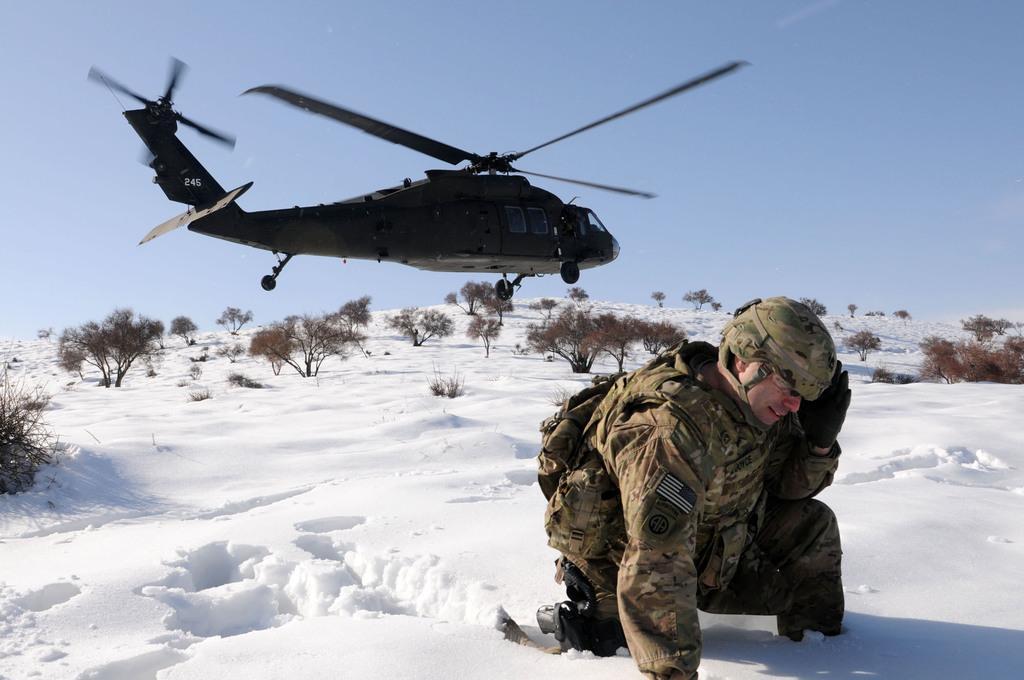In one or two sentences, can you explain what this image depicts? In this picture we can see a person on snow, trees, helicopter in the air and in the background we can see the sky. 